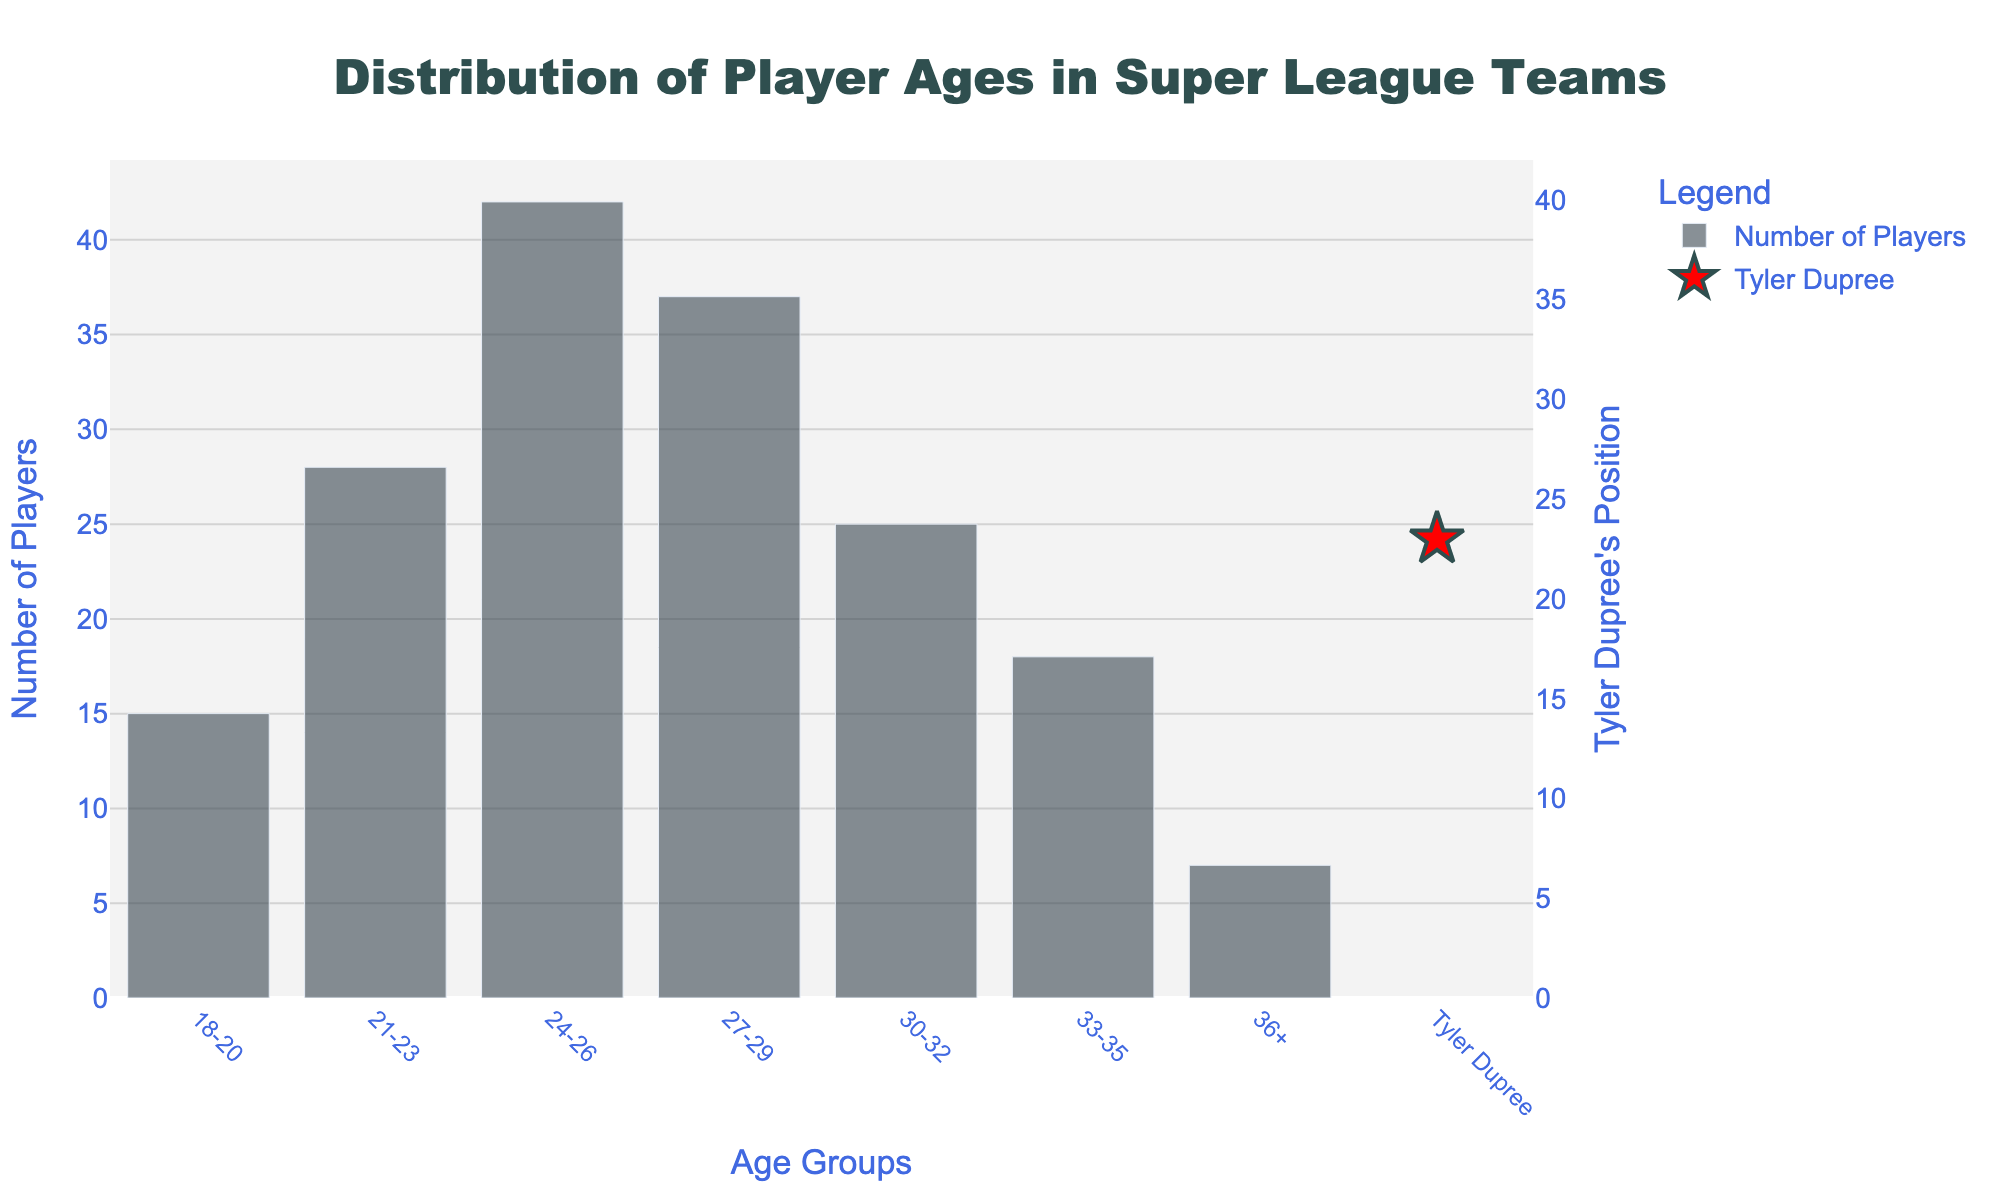Which age group has the highest number of players? The age groups and their respective counts of players are listed as 18-20 having 15 players, 21-23 having 28 players, 24-26 having 42 players, 27-29 having 37 players, 30-32 having 25 players, 33-35 having 18 players, and 36+ having 7 players. The age group with the highest number of players is 24-26 with 42 players.
Answer: 24-26 How does the number of players in the age group 24-26 compare with the number of players in the age group 18-20? The number of players in the age group 24-26 is 42, and in the age group 18-20 is 15. Therefore, the number of players in the age group 24-26 is greater than that in the age group 18-20 by 42 - 15 = 27 players.
Answer: 27 more players Where is Tyler Dupree positioned on the chart? Tyler Dupree is represented with a red star marker on the chart. His data point is highlighted separately at the age of 23.
Answer: Age 23 What's the total number of players under the age of 27? Add the number of players in the age groups 18-20, 21-23, and 24-26. So, 15 (18-20) + 28 (21-23) + 42 (24-26) = 85 players.
Answer: 85 How many more players are there in the age group 27-29 compared to the age group 33-35? The age group 27-29 has 37 players and the age group 33-35 has 18 players. So, the difference is 37 - 18 = 19 players.
Answer: 19 more players What is the average number of players in all the age groups excluding Tyler Dupree? Add up the number of players in all age groups and then divide by the number of age groups. So, (15 + 28 + 42 + 37 + 25 + 18 + 7) / 7 = 172 / 7 ≈ 24.57 players.
Answer: ≈ 24.57 Which age group has the least number of players, and how many players are in that group? The age groups and their respective counts are: 18-20 (15), 21-23 (28), 24-26 (42), 27-29 (37), 30-32 (25), 33-35 (18), and 36+ (7). The age group 36+ has the least number of players, which is 7.
Answer: 36+, 7 Is Tyler Dupree's age above or below the average age group with the highest number of players? Tyler Dupree is 23 years old. The age group with the highest number of players is 24-26. Since 23 is below 24-26, Tyler Dupree's age is below the average age group with the highest number of players.
Answer: Below What is the cumulative number of players aged 30 or older? Add the number of players in age groups 30-32, 33-35, and 36+. So, 25 (30-32) + 18 (33-35) + 7 (36+) = 50 players.
Answer: 50 How many player age groups have fewer than 20 players? The age groups with fewer than 20 players are 18-20 (15 players), 33-35 (18 players), and 36+ (7 players), totaling 3 age groups.
Answer: 3 